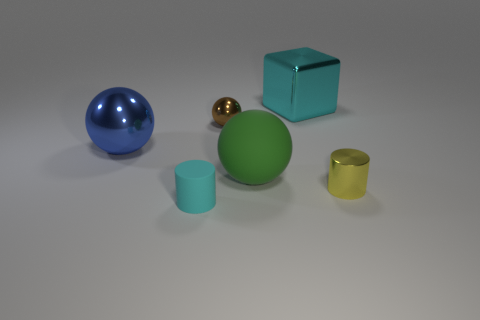Add 2 large matte balls. How many objects exist? 8 Subtract all blue balls. How many balls are left? 2 Subtract all tiny balls. How many balls are left? 2 Subtract all blocks. How many objects are left? 5 Subtract 2 cylinders. How many cylinders are left? 0 Add 5 small brown shiny spheres. How many small brown shiny spheres are left? 6 Add 5 tiny brown metal blocks. How many tiny brown metal blocks exist? 5 Subtract 0 brown blocks. How many objects are left? 6 Subtract all brown blocks. Subtract all yellow cylinders. How many blocks are left? 1 Subtract all cyan blocks. How many green cylinders are left? 0 